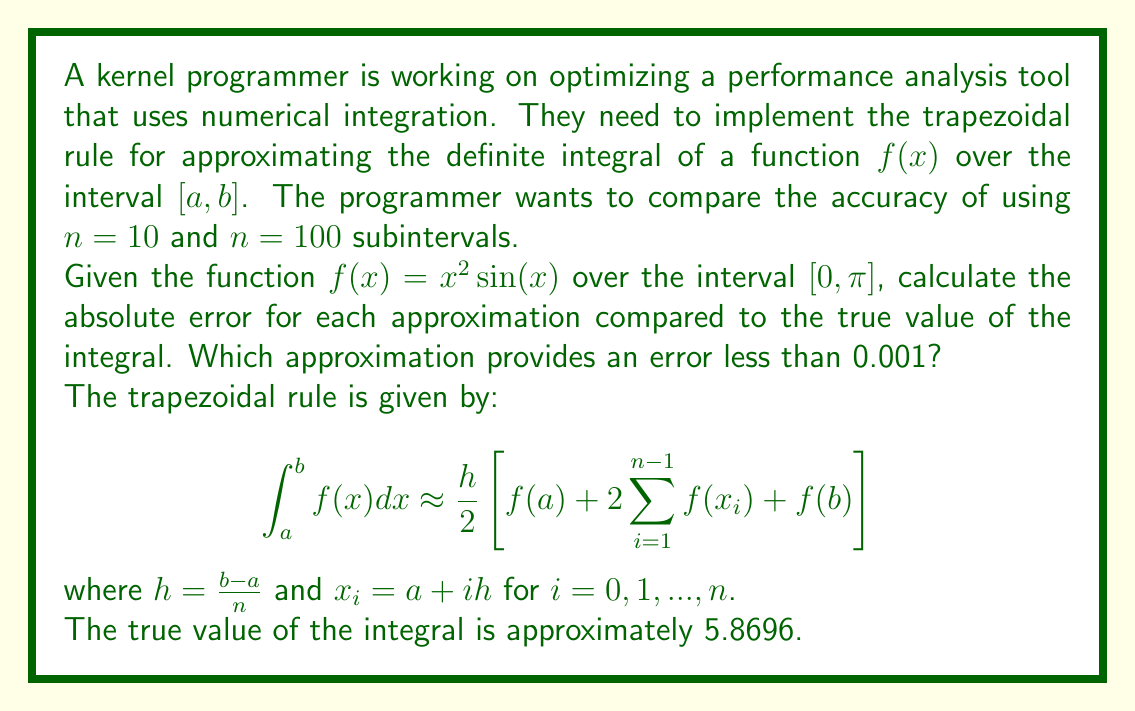Teach me how to tackle this problem. To solve this problem, we need to implement the trapezoidal rule for both $n=10$ and $n=100$, then compare the results to the true value.

1. For $n=10$:
   $h = \frac{\pi - 0}{10} = \frac{\pi}{10}$
   
   $$\begin{align*}
   I_{10} &= \frac{\pi}{20}\left[f(0) + 2\sum_{i=1}^{9}f(i\frac{\pi}{10}) + f(\pi)\right] \\
   &= \frac{\pi}{20}\left[0 + 2\sum_{i=1}^{9}(i\frac{\pi}{10})^2\sin(i\frac{\pi}{10}) + \pi^2\sin(\pi)\right] \\
   &\approx 5.8442
   \end{align*}$$

   Absolute error: $|5.8696 - 5.8442| = 0.0254$

2. For $n=100$:
   $h = \frac{\pi - 0}{100} = \frac{\pi}{100}$
   
   $$\begin{align*}
   I_{100} &= \frac{\pi}{200}\left[f(0) + 2\sum_{i=1}^{99}f(i\frac{\pi}{100}) + f(\pi)\right] \\
   &= \frac{\pi}{200}\left[0 + 2\sum_{i=1}^{99}(i\frac{\pi}{100})^2\sin(i\frac{\pi}{100}) + \pi^2\sin(\pi)\right] \\
   &\approx 5.8694
   \end{align*}$$

   Absolute error: $|5.8696 - 5.8694| = 0.0002$

Comparing the results:
- For $n=10$, the absolute error is 0.0254
- For $n=100$, the absolute error is 0.0002

The approximation with $n=100$ provides an error less than 0.001, while the approximation with $n=10$ does not.
Answer: The approximation with $n=100$ subintervals provides an error less than 0.001, with an absolute error of 0.0002. 